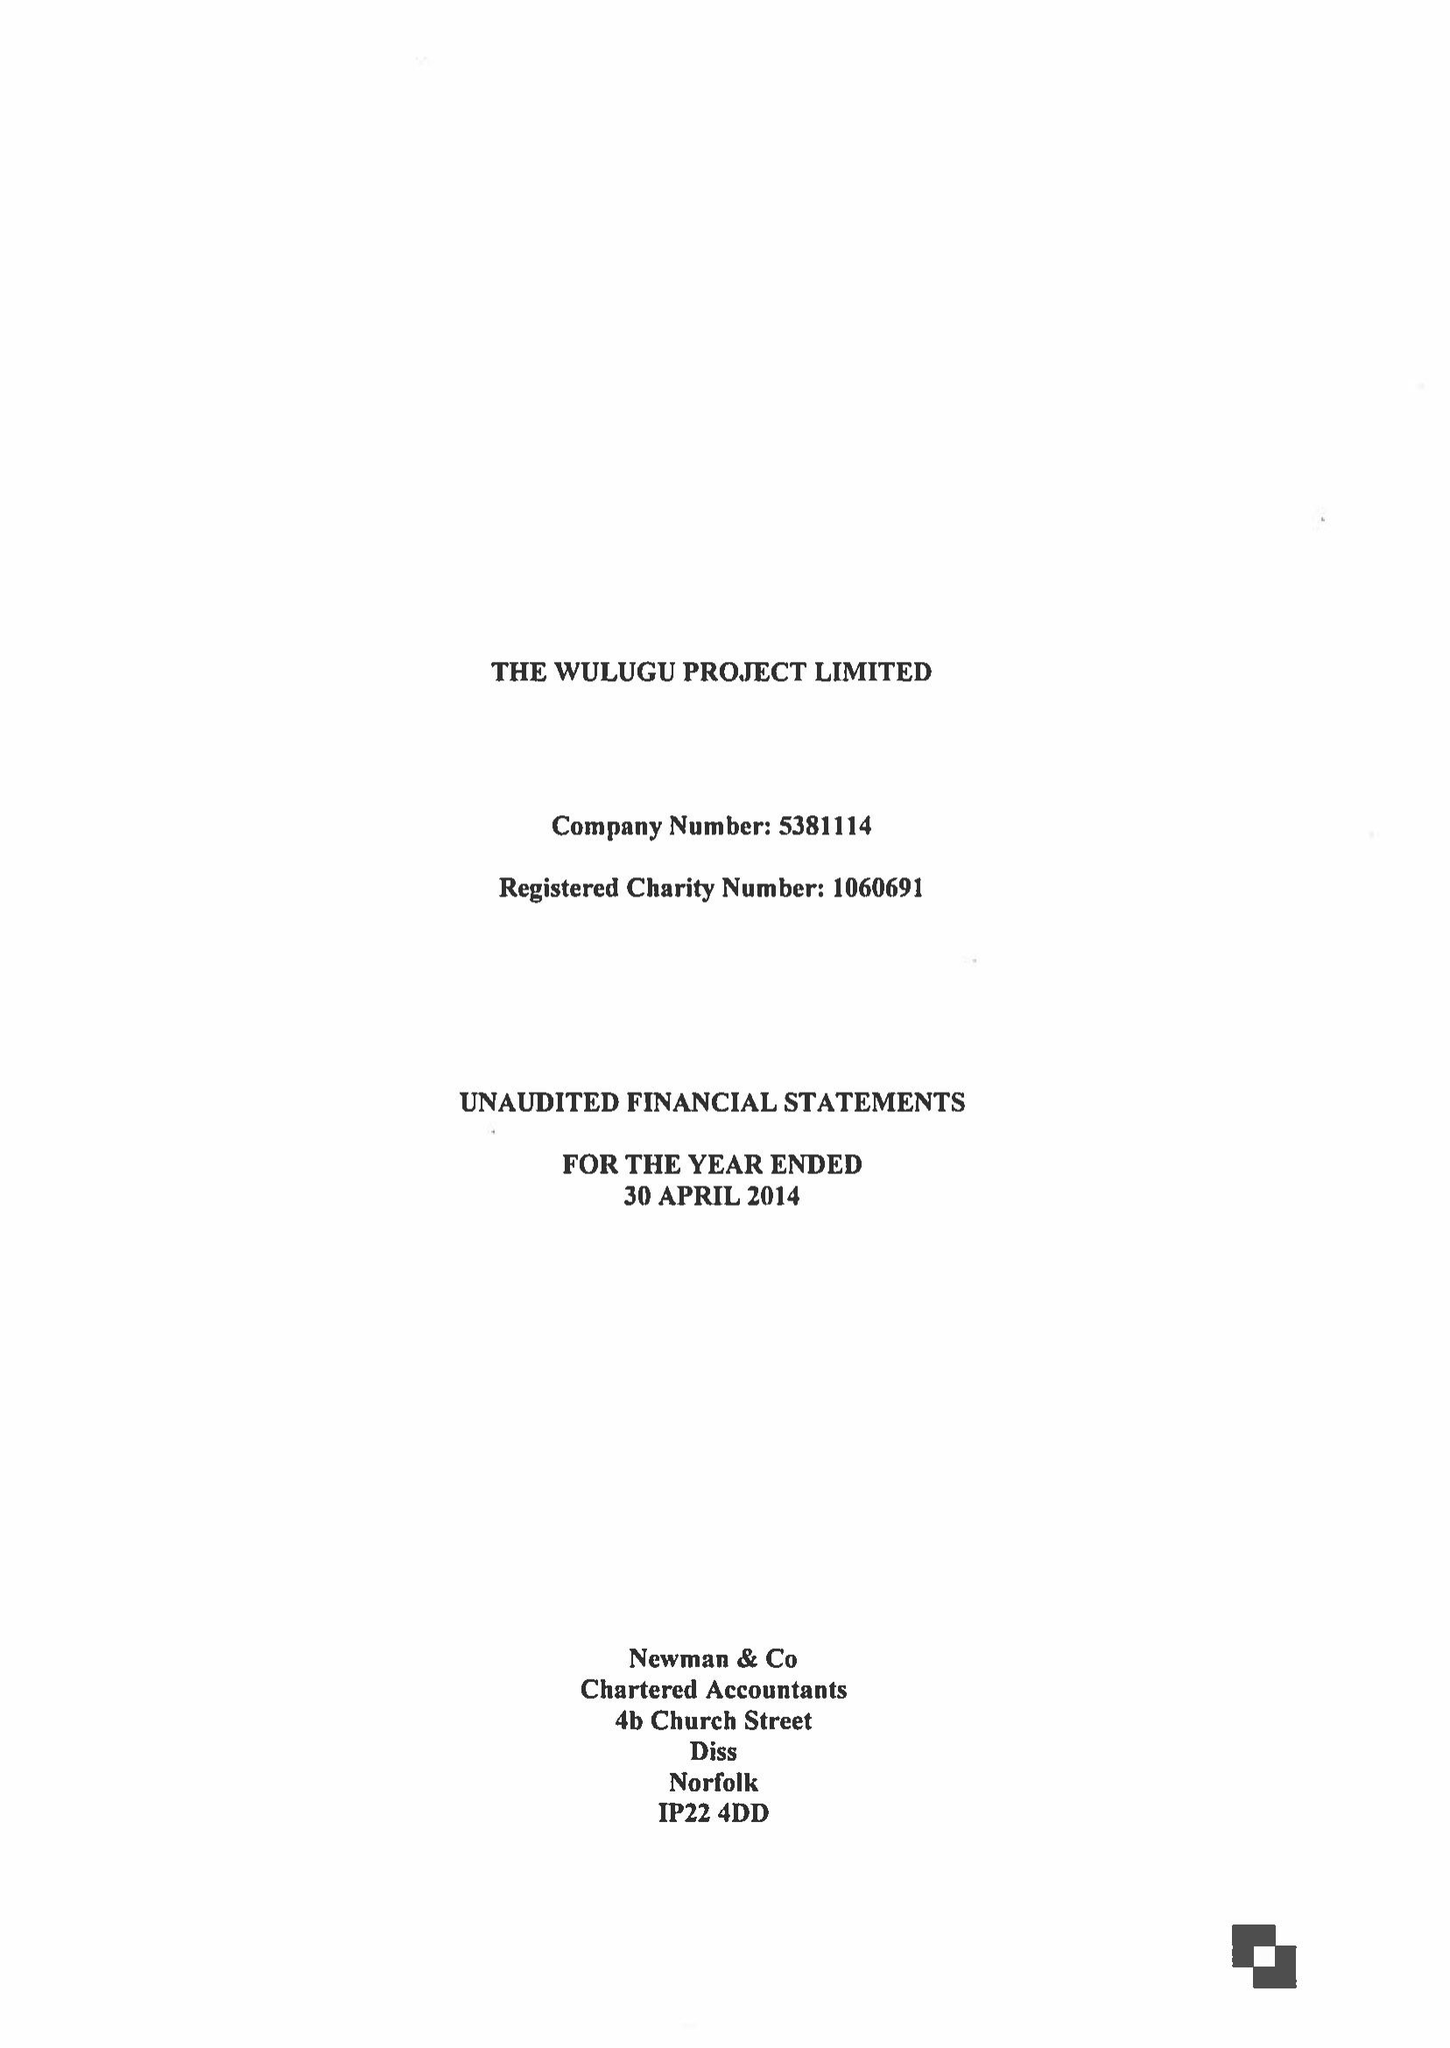What is the value for the report_date?
Answer the question using a single word or phrase. 2014-04-30 